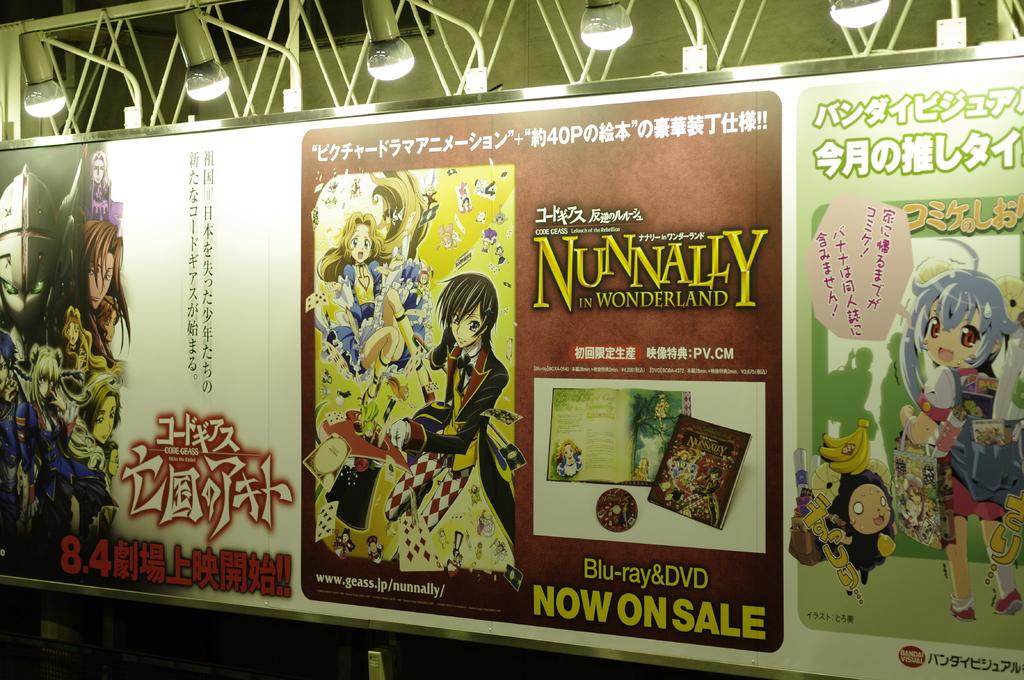When is it on sale?
Make the answer very short. Now. 